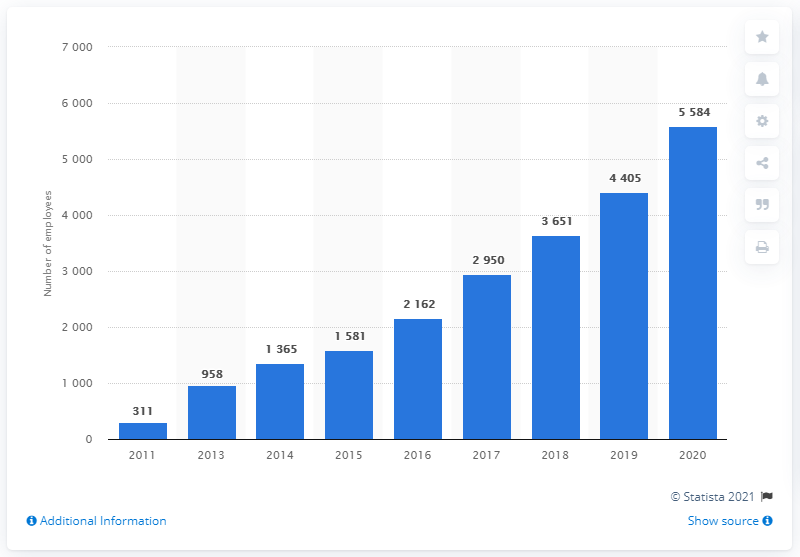Specify some key components in this picture. In 2011, Spotify employed 311 people. 